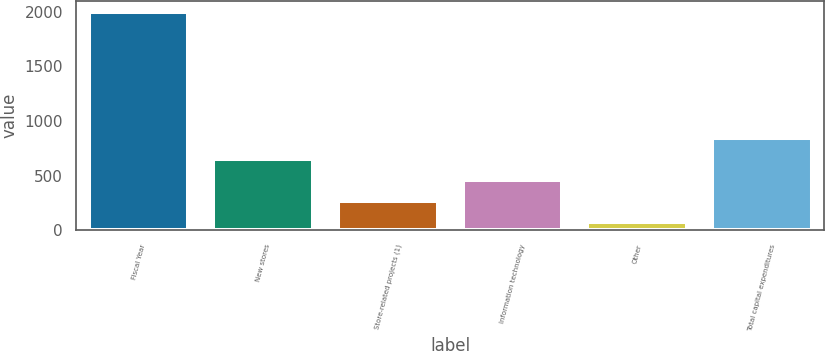Convert chart to OTSL. <chart><loc_0><loc_0><loc_500><loc_500><bar_chart><fcel>Fiscal Year<fcel>New stores<fcel>Store-related projects (1)<fcel>Information technology<fcel>Other<fcel>Total capital expenditures<nl><fcel>2004<fcel>655.8<fcel>270.6<fcel>463.2<fcel>78<fcel>848.4<nl></chart> 